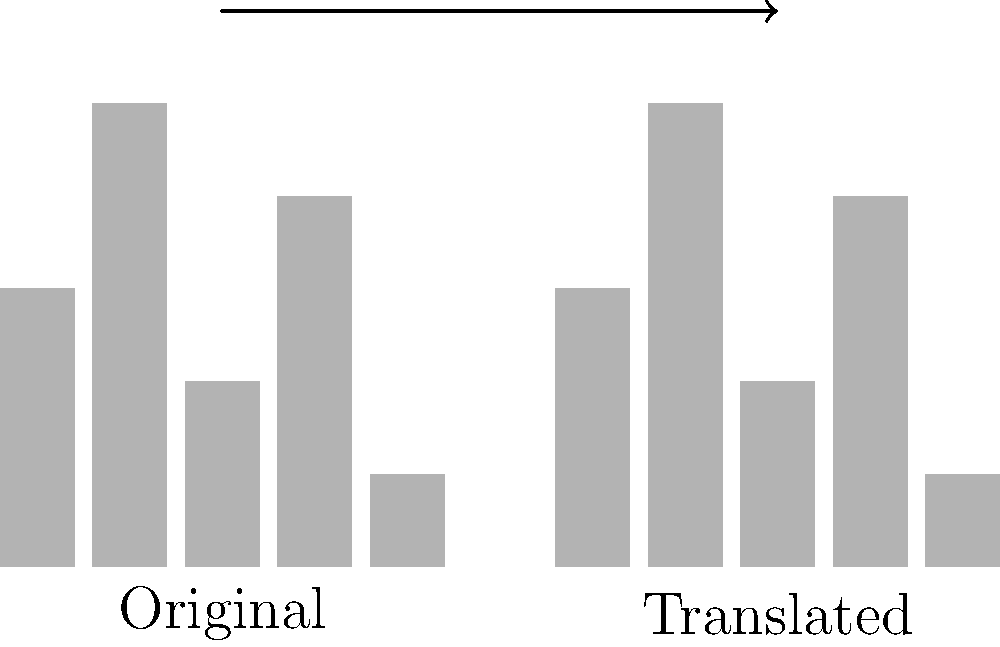In the equalizer display above, a sequence of 5 bars represents a visual rhythm pattern. If this pattern is translated 6 units to the right, what would be the new coordinates of the middle bar in the translated sequence? To solve this problem, let's follow these steps:

1. Identify the original position of the middle bar:
   - The original sequence has 5 bars.
   - The middle bar is the 3rd bar (at position 3 on the x-axis).
   - Its height is 2 units.

2. Determine the translation:
   - The question states that the pattern is translated 6 units to the right.
   - This means we add 6 to the x-coordinate.

3. Calculate the new position:
   - Original x-coordinate: 3
   - Translation: +6
   - New x-coordinate: $3 + 6 = 9$

4. Consider the y-coordinate:
   - The y-coordinate (height) doesn't change in a horizontal translation.
   - The height remains 2 units.

5. Express the new position as coordinates:
   - The new position of the middle bar is (9, 2).
Answer: (9, 2) 